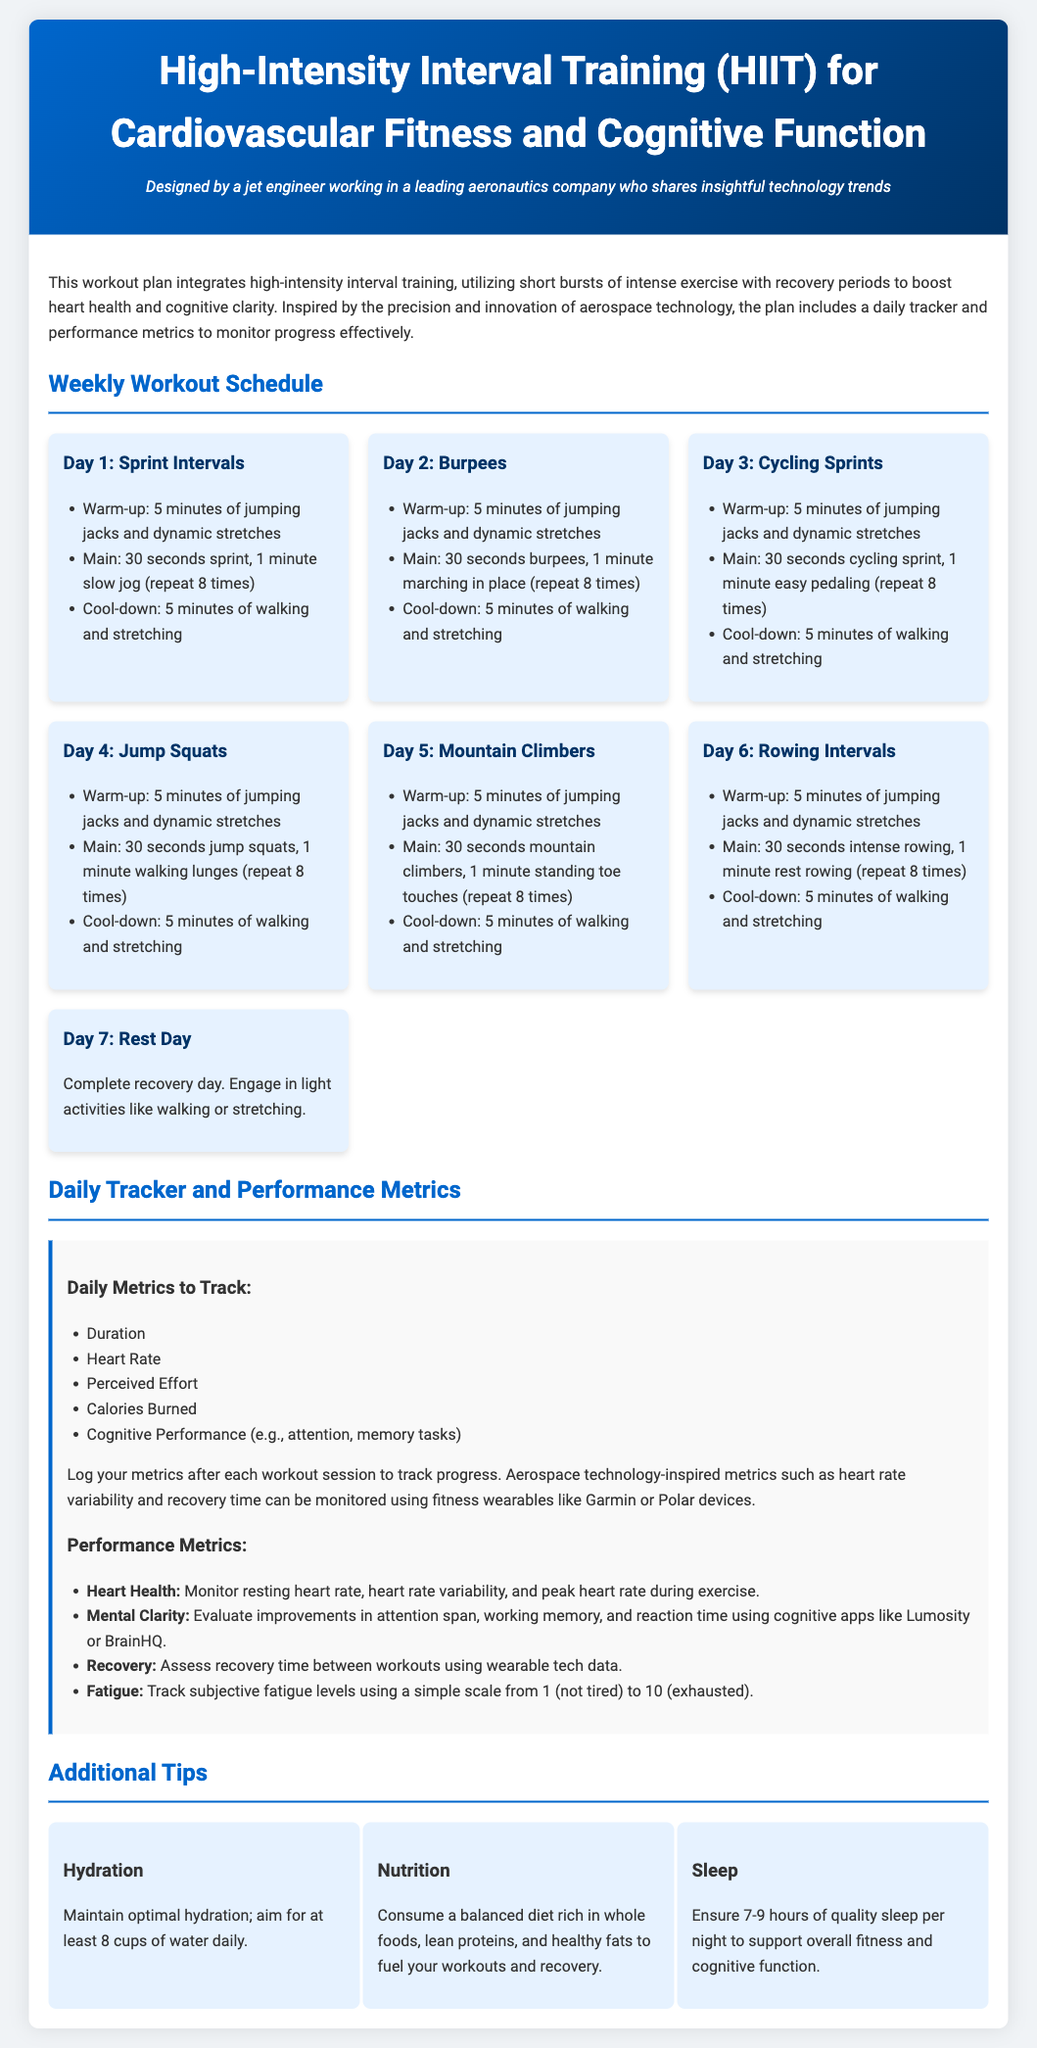What is the title of the workout plan? The title is the heading of the document that indicates the main focus of the content.
Answer: High-Intensity Interval Training (HIIT) for Cardiovascular Fitness and Cognitive Function How many days are included in the workout schedule? The workout schedule is structured into a weekly outline, indicating the number of days of activities.
Answer: 7 days What is the main exercise for Day 3? The main exercise for Day 3 is specified in the workout description for that day.
Answer: Cycling Sprints What are the performance metrics listed in the document? The document outlines specific performance metrics as part of tracking for improved results, detailing what to monitor.
Answer: Heart Health, Mental Clarity, Recovery, Fatigue What duration of sleep is recommended in the tips? The tips section provides specific guidance on sleep duration for optimal fitness and cognitive support.
Answer: 7-9 hours 